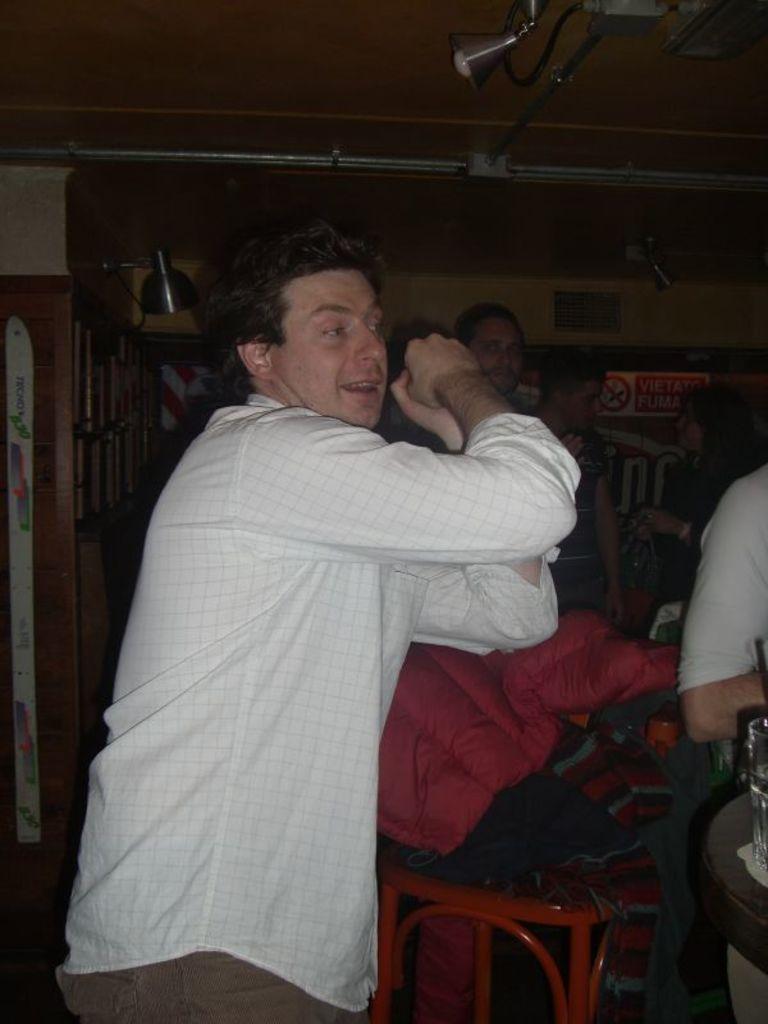In one or two sentences, can you explain what this image depicts? In this image, there are a few people. We can also see some clothes on the wooden object. In the background, we can see the wall with some wood. We can also see a board with some text. We can see the roof with some objects attached to it. 